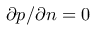Convert formula to latex. <formula><loc_0><loc_0><loc_500><loc_500>\partial p / \partial n = 0</formula> 